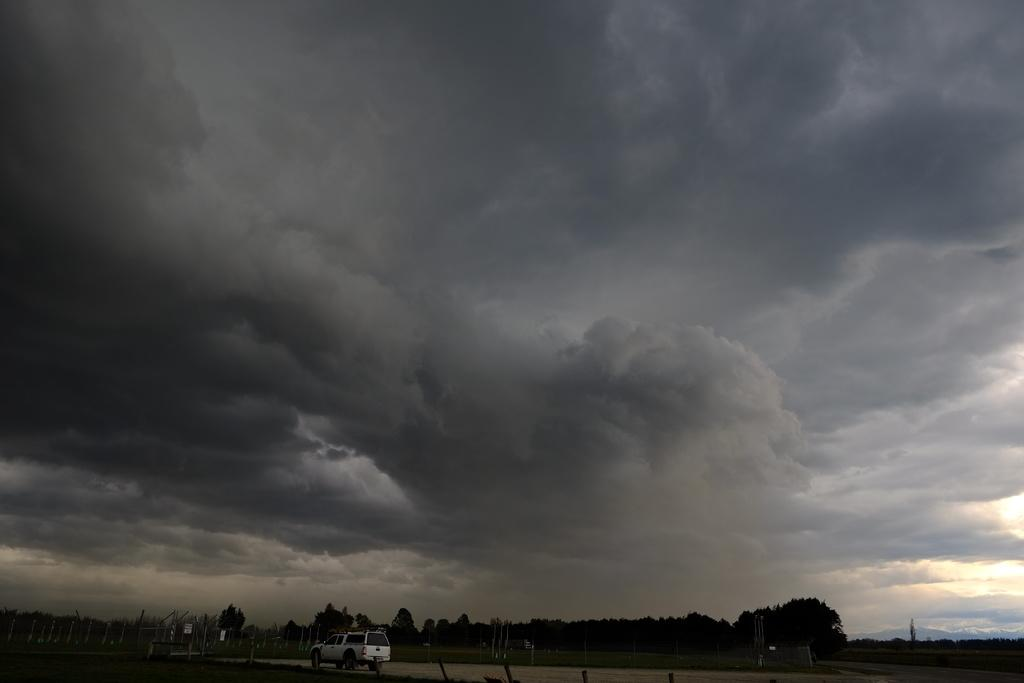What is located in the foreground of the image? There is a vehicle and trees in the foreground of the image. What else can be seen in the foreground of the image? There is a road in the foreground of the image. What is visible at the top of the image? The sky is visible at the top of the image. Can you see any tigers flying planes in the image? There are no tigers or planes present in the image. Is there a washing machine visible in the image? There is no washing machine present in the image. 